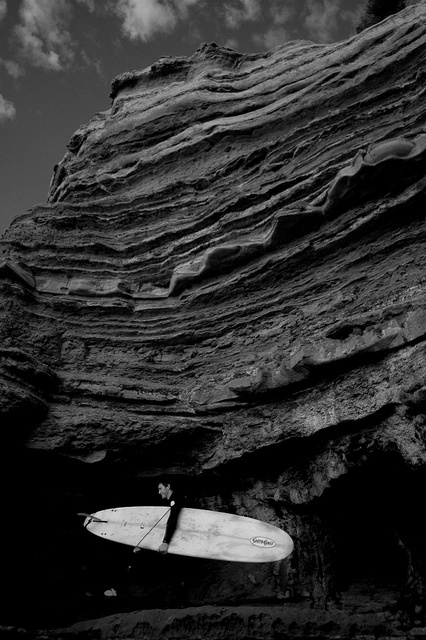Describe the objects in this image and their specific colors. I can see surfboard in gray, darkgray, lightgray, and black tones and people in gray, black, darkgray, and lightgray tones in this image. 